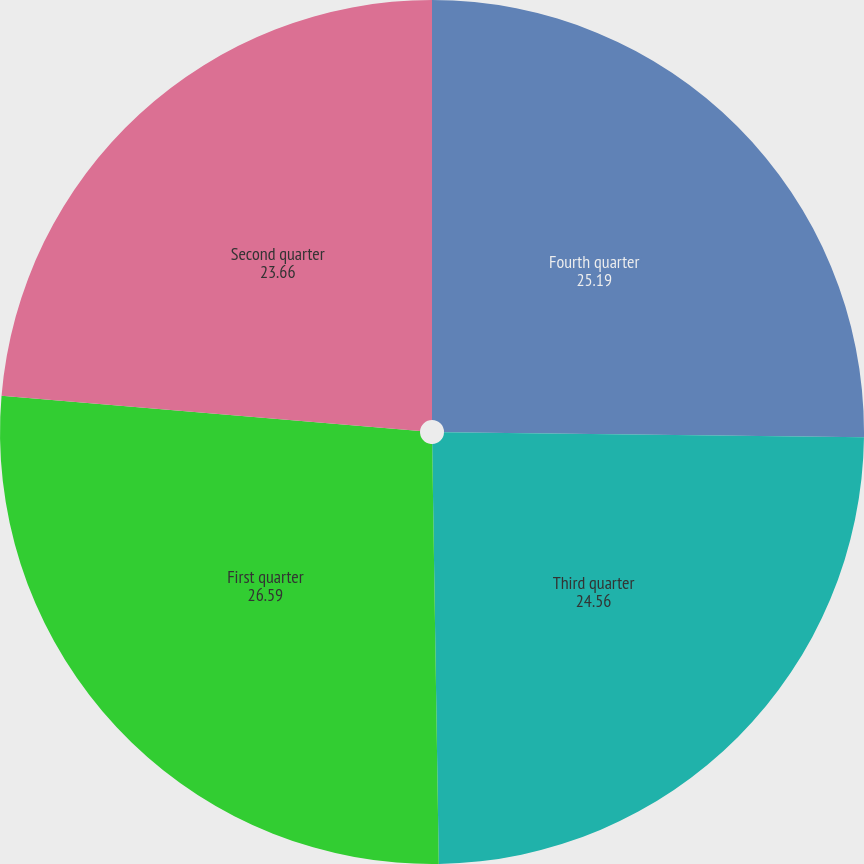Convert chart. <chart><loc_0><loc_0><loc_500><loc_500><pie_chart><fcel>Fourth quarter<fcel>Third quarter<fcel>First quarter<fcel>Second quarter<nl><fcel>25.19%<fcel>24.56%<fcel>26.59%<fcel>23.66%<nl></chart> 